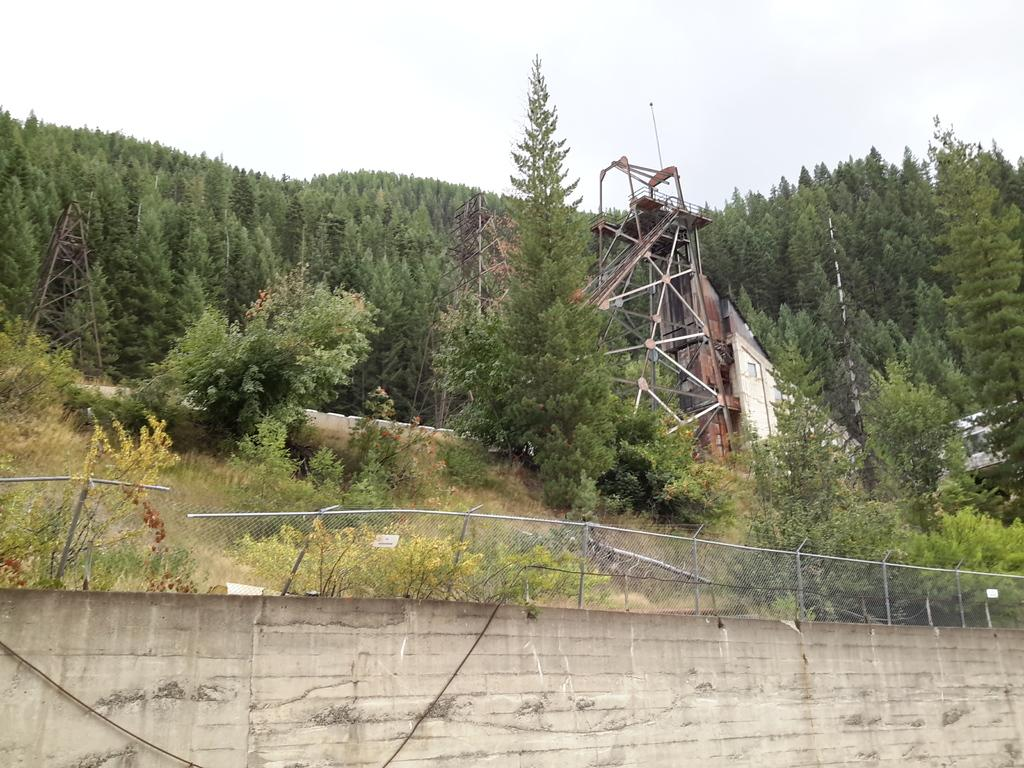What type of structure is present in the image? There is a wall with fencing in the image. What can be seen behind the wall? Grass, plants, and trees are visible behind the wall. What is visible in the sky in the image? The sky is visible in the image. What type of grain is being harvested in the image? There is no grain present in the image; it features a wall with fencing and natural elements behind it. How many frogs can be seen hopping around in the image? There are no frogs present in the image. 